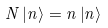<formula> <loc_0><loc_0><loc_500><loc_500>N \left | n \right \rangle = n \left | n \right \rangle</formula> 